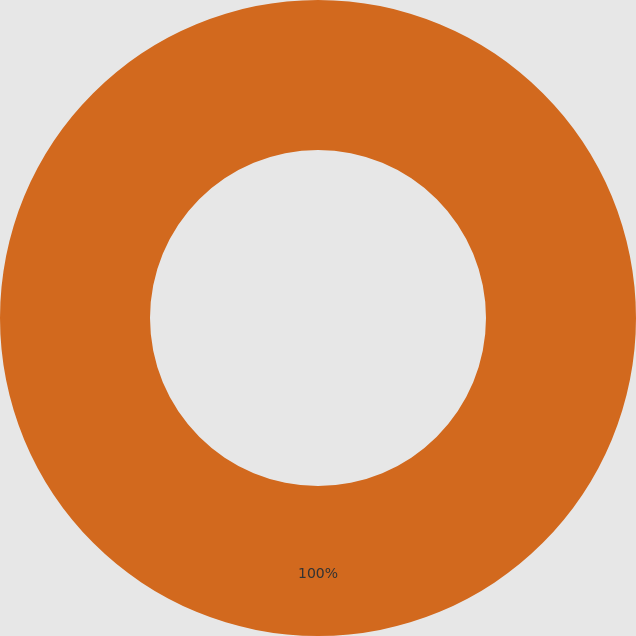Convert chart to OTSL. <chart><loc_0><loc_0><loc_500><loc_500><pie_chart><ecel><nl><fcel>100.0%<nl></chart> 